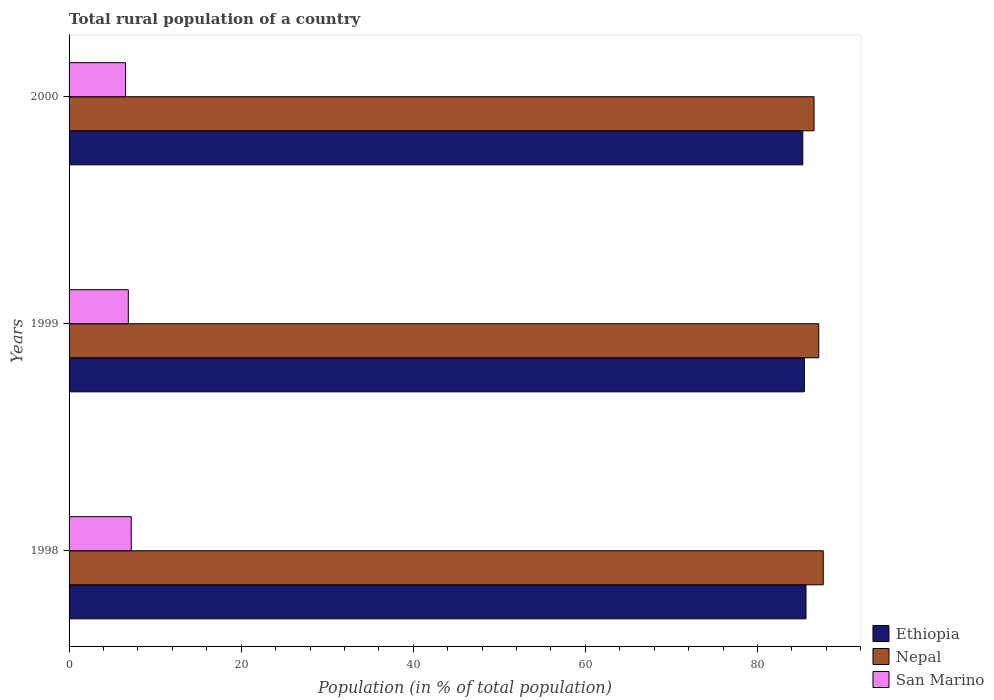How many different coloured bars are there?
Your response must be concise. 3. Are the number of bars per tick equal to the number of legend labels?
Keep it short and to the point. Yes. How many bars are there on the 2nd tick from the top?
Your response must be concise. 3. How many bars are there on the 3rd tick from the bottom?
Your answer should be very brief. 3. In how many cases, is the number of bars for a given year not equal to the number of legend labels?
Offer a very short reply. 0. What is the rural population in Ethiopia in 1999?
Keep it short and to the point. 85.45. Across all years, what is the maximum rural population in Ethiopia?
Your answer should be compact. 85.63. Across all years, what is the minimum rural population in Nepal?
Provide a short and direct response. 86.57. In which year was the rural population in Ethiopia maximum?
Provide a short and direct response. 1998. What is the total rural population in Nepal in the graph?
Your response must be concise. 261.32. What is the difference between the rural population in San Marino in 1998 and that in 2000?
Offer a terse response. 0.66. What is the difference between the rural population in San Marino in 1998 and the rural population in Ethiopia in 1999?
Your response must be concise. -78.22. What is the average rural population in Nepal per year?
Your answer should be very brief. 87.11. In the year 1999, what is the difference between the rural population in Ethiopia and rural population in San Marino?
Offer a terse response. 78.56. What is the ratio of the rural population in Ethiopia in 1999 to that in 2000?
Give a very brief answer. 1. Is the rural population in Ethiopia in 1998 less than that in 2000?
Offer a very short reply. No. What is the difference between the highest and the second highest rural population in Nepal?
Provide a succinct answer. 0.53. What is the difference between the highest and the lowest rural population in San Marino?
Your response must be concise. 0.66. Is the sum of the rural population in Ethiopia in 1998 and 2000 greater than the maximum rural population in Nepal across all years?
Give a very brief answer. Yes. What does the 3rd bar from the top in 1998 represents?
Give a very brief answer. Ethiopia. What does the 1st bar from the bottom in 1998 represents?
Offer a terse response. Ethiopia. How many bars are there?
Give a very brief answer. 9. Are all the bars in the graph horizontal?
Provide a short and direct response. Yes. How many years are there in the graph?
Keep it short and to the point. 3. What is the difference between two consecutive major ticks on the X-axis?
Your response must be concise. 20. Are the values on the major ticks of X-axis written in scientific E-notation?
Ensure brevity in your answer.  No. Does the graph contain any zero values?
Give a very brief answer. No. Does the graph contain grids?
Make the answer very short. No. How many legend labels are there?
Provide a short and direct response. 3. How are the legend labels stacked?
Give a very brief answer. Vertical. What is the title of the graph?
Your answer should be very brief. Total rural population of a country. Does "Slovenia" appear as one of the legend labels in the graph?
Offer a terse response. No. What is the label or title of the X-axis?
Offer a very short reply. Population (in % of total population). What is the label or title of the Y-axis?
Make the answer very short. Years. What is the Population (in % of total population) in Ethiopia in 1998?
Keep it short and to the point. 85.63. What is the Population (in % of total population) in Nepal in 1998?
Give a very brief answer. 87.64. What is the Population (in % of total population) in San Marino in 1998?
Your answer should be compact. 7.22. What is the Population (in % of total population) in Ethiopia in 1999?
Ensure brevity in your answer.  85.45. What is the Population (in % of total population) in Nepal in 1999?
Provide a succinct answer. 87.11. What is the Population (in % of total population) of San Marino in 1999?
Provide a succinct answer. 6.89. What is the Population (in % of total population) in Ethiopia in 2000?
Provide a succinct answer. 85.26. What is the Population (in % of total population) of Nepal in 2000?
Your answer should be compact. 86.57. What is the Population (in % of total population) of San Marino in 2000?
Offer a terse response. 6.56. Across all years, what is the maximum Population (in % of total population) of Ethiopia?
Give a very brief answer. 85.63. Across all years, what is the maximum Population (in % of total population) of Nepal?
Provide a short and direct response. 87.64. Across all years, what is the maximum Population (in % of total population) of San Marino?
Keep it short and to the point. 7.22. Across all years, what is the minimum Population (in % of total population) in Ethiopia?
Ensure brevity in your answer.  85.26. Across all years, what is the minimum Population (in % of total population) in Nepal?
Make the answer very short. 86.57. Across all years, what is the minimum Population (in % of total population) in San Marino?
Offer a terse response. 6.56. What is the total Population (in % of total population) of Ethiopia in the graph?
Make the answer very short. 256.34. What is the total Population (in % of total population) of Nepal in the graph?
Ensure brevity in your answer.  261.32. What is the total Population (in % of total population) of San Marino in the graph?
Make the answer very short. 20.67. What is the difference between the Population (in % of total population) of Ethiopia in 1998 and that in 1999?
Offer a terse response. 0.18. What is the difference between the Population (in % of total population) in Nepal in 1998 and that in 1999?
Offer a very short reply. 0.53. What is the difference between the Population (in % of total population) in San Marino in 1998 and that in 1999?
Provide a succinct answer. 0.34. What is the difference between the Population (in % of total population) of Ethiopia in 1998 and that in 2000?
Offer a terse response. 0.37. What is the difference between the Population (in % of total population) in Nepal in 1998 and that in 2000?
Ensure brevity in your answer.  1.07. What is the difference between the Population (in % of total population) in San Marino in 1998 and that in 2000?
Ensure brevity in your answer.  0.66. What is the difference between the Population (in % of total population) in Ethiopia in 1999 and that in 2000?
Your response must be concise. 0.19. What is the difference between the Population (in % of total population) in Nepal in 1999 and that in 2000?
Give a very brief answer. 0.55. What is the difference between the Population (in % of total population) of San Marino in 1999 and that in 2000?
Your answer should be compact. 0.33. What is the difference between the Population (in % of total population) of Ethiopia in 1998 and the Population (in % of total population) of Nepal in 1999?
Give a very brief answer. -1.48. What is the difference between the Population (in % of total population) in Ethiopia in 1998 and the Population (in % of total population) in San Marino in 1999?
Make the answer very short. 78.75. What is the difference between the Population (in % of total population) in Nepal in 1998 and the Population (in % of total population) in San Marino in 1999?
Keep it short and to the point. 80.75. What is the difference between the Population (in % of total population) in Ethiopia in 1998 and the Population (in % of total population) in Nepal in 2000?
Give a very brief answer. -0.94. What is the difference between the Population (in % of total population) of Ethiopia in 1998 and the Population (in % of total population) of San Marino in 2000?
Your answer should be compact. 79.07. What is the difference between the Population (in % of total population) in Nepal in 1998 and the Population (in % of total population) in San Marino in 2000?
Your answer should be very brief. 81.08. What is the difference between the Population (in % of total population) of Ethiopia in 1999 and the Population (in % of total population) of Nepal in 2000?
Offer a terse response. -1.12. What is the difference between the Population (in % of total population) in Ethiopia in 1999 and the Population (in % of total population) in San Marino in 2000?
Ensure brevity in your answer.  78.89. What is the difference between the Population (in % of total population) of Nepal in 1999 and the Population (in % of total population) of San Marino in 2000?
Offer a very short reply. 80.55. What is the average Population (in % of total population) in Ethiopia per year?
Ensure brevity in your answer.  85.45. What is the average Population (in % of total population) in Nepal per year?
Ensure brevity in your answer.  87.11. What is the average Population (in % of total population) of San Marino per year?
Provide a short and direct response. 6.89. In the year 1998, what is the difference between the Population (in % of total population) in Ethiopia and Population (in % of total population) in Nepal?
Keep it short and to the point. -2.01. In the year 1998, what is the difference between the Population (in % of total population) in Ethiopia and Population (in % of total population) in San Marino?
Provide a succinct answer. 78.41. In the year 1998, what is the difference between the Population (in % of total population) of Nepal and Population (in % of total population) of San Marino?
Offer a terse response. 80.42. In the year 1999, what is the difference between the Population (in % of total population) in Ethiopia and Population (in % of total population) in Nepal?
Your answer should be compact. -1.67. In the year 1999, what is the difference between the Population (in % of total population) in Ethiopia and Population (in % of total population) in San Marino?
Provide a short and direct response. 78.56. In the year 1999, what is the difference between the Population (in % of total population) in Nepal and Population (in % of total population) in San Marino?
Offer a very short reply. 80.23. In the year 2000, what is the difference between the Population (in % of total population) of Ethiopia and Population (in % of total population) of Nepal?
Keep it short and to the point. -1.31. In the year 2000, what is the difference between the Population (in % of total population) of Ethiopia and Population (in % of total population) of San Marino?
Give a very brief answer. 78.7. In the year 2000, what is the difference between the Population (in % of total population) of Nepal and Population (in % of total population) of San Marino?
Provide a succinct answer. 80.01. What is the ratio of the Population (in % of total population) of Ethiopia in 1998 to that in 1999?
Give a very brief answer. 1. What is the ratio of the Population (in % of total population) of San Marino in 1998 to that in 1999?
Make the answer very short. 1.05. What is the ratio of the Population (in % of total population) of Nepal in 1998 to that in 2000?
Give a very brief answer. 1.01. What is the ratio of the Population (in % of total population) in San Marino in 1998 to that in 2000?
Ensure brevity in your answer.  1.1. What is the ratio of the Population (in % of total population) of Ethiopia in 1999 to that in 2000?
Your answer should be very brief. 1. What is the ratio of the Population (in % of total population) in Nepal in 1999 to that in 2000?
Make the answer very short. 1.01. What is the ratio of the Population (in % of total population) of San Marino in 1999 to that in 2000?
Your answer should be compact. 1.05. What is the difference between the highest and the second highest Population (in % of total population) in Ethiopia?
Offer a terse response. 0.18. What is the difference between the highest and the second highest Population (in % of total population) in Nepal?
Provide a short and direct response. 0.53. What is the difference between the highest and the second highest Population (in % of total population) in San Marino?
Your answer should be compact. 0.34. What is the difference between the highest and the lowest Population (in % of total population) in Ethiopia?
Offer a very short reply. 0.37. What is the difference between the highest and the lowest Population (in % of total population) of Nepal?
Your answer should be compact. 1.07. What is the difference between the highest and the lowest Population (in % of total population) in San Marino?
Make the answer very short. 0.66. 